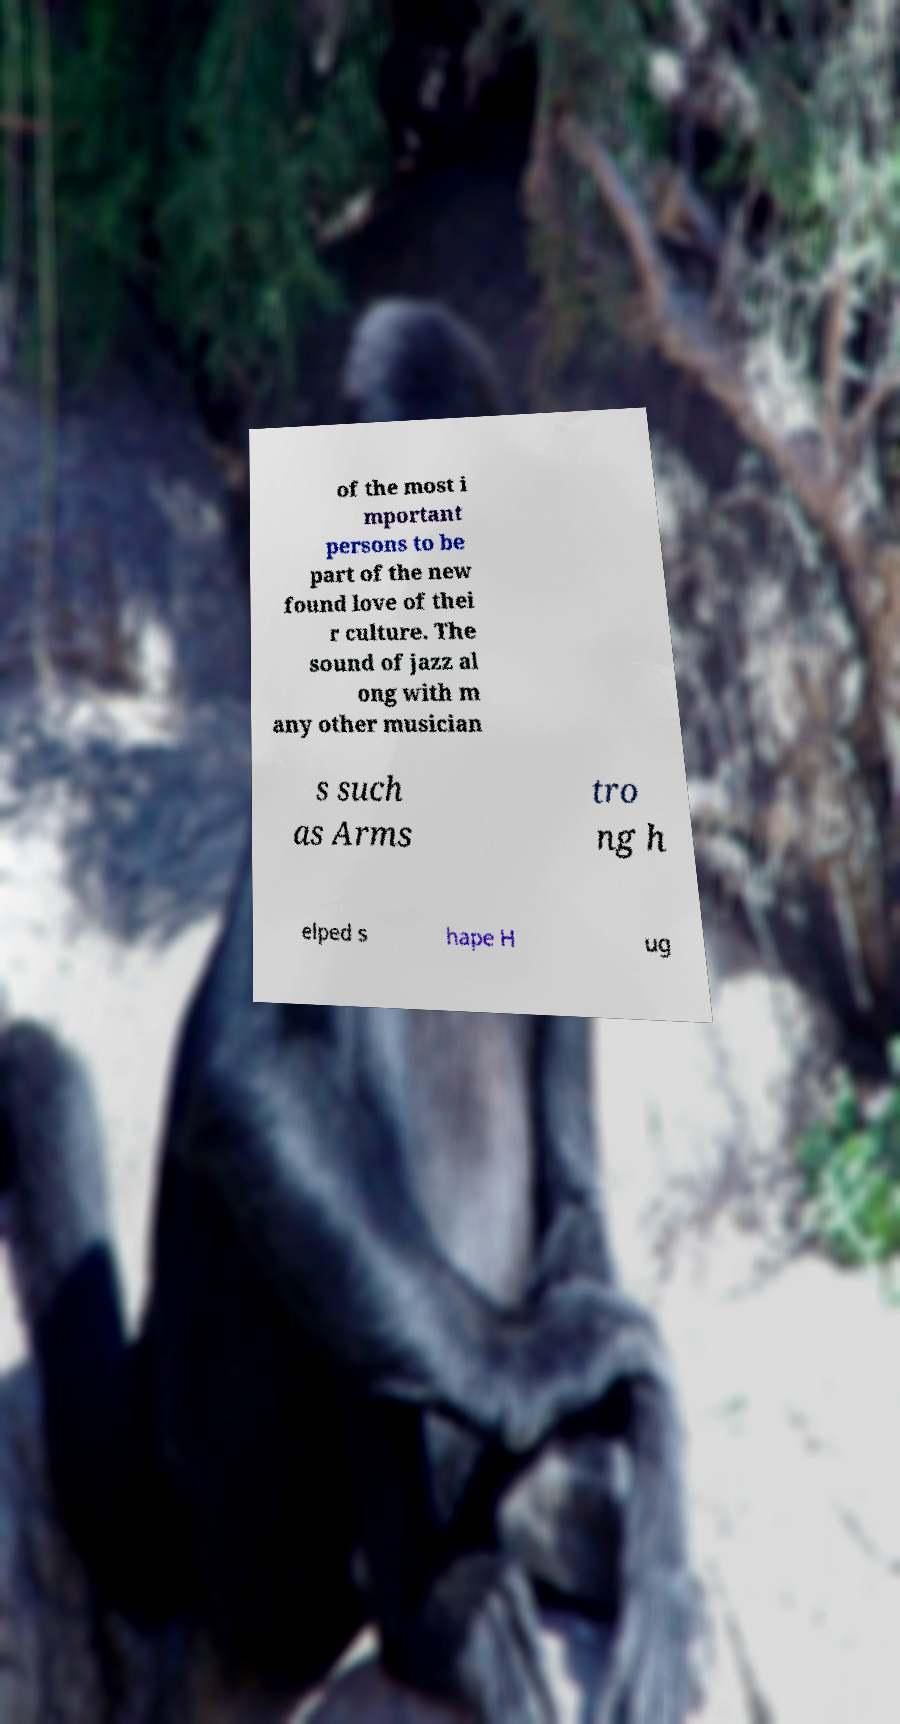Please identify and transcribe the text found in this image. of the most i mportant persons to be part of the new found love of thei r culture. The sound of jazz al ong with m any other musician s such as Arms tro ng h elped s hape H ug 